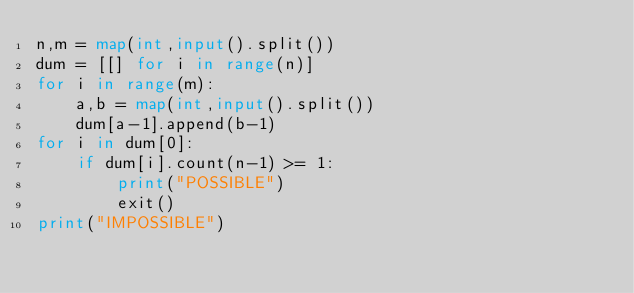<code> <loc_0><loc_0><loc_500><loc_500><_Python_>n,m = map(int,input().split())
dum = [[] for i in range(n)]
for i in range(m):
    a,b = map(int,input().split())
    dum[a-1].append(b-1)
for i in dum[0]:
    if dum[i].count(n-1) >= 1:
        print("POSSIBLE")
        exit()
print("IMPOSSIBLE")</code> 